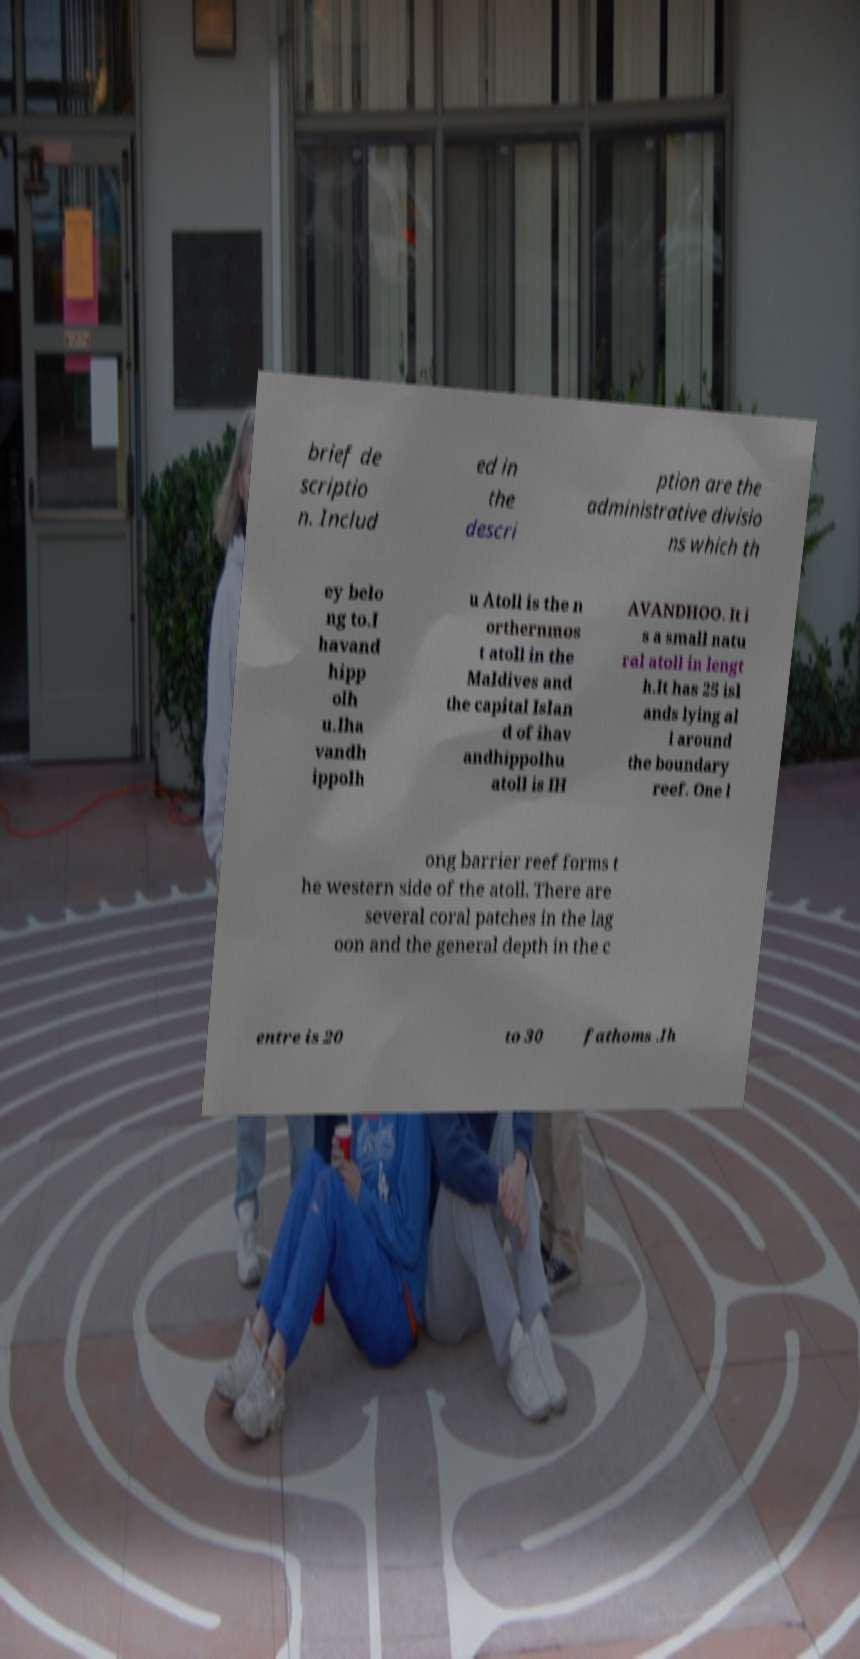There's text embedded in this image that I need extracted. Can you transcribe it verbatim? brief de scriptio n. Includ ed in the descri ption are the administrative divisio ns which th ey belo ng to.I havand hipp olh u.Iha vandh ippolh u Atoll is the n orthernmos t atoll in the Maldives and the capital Islan d of ihav andhippolhu atoll is IH AVANDHOO. It i s a small natu ral atoll in lengt h.It has 25 isl ands lying al l around the boundary reef. One l ong barrier reef forms t he western side of the atoll. There are several coral patches in the lag oon and the general depth in the c entre is 20 to 30 fathoms .Ih 